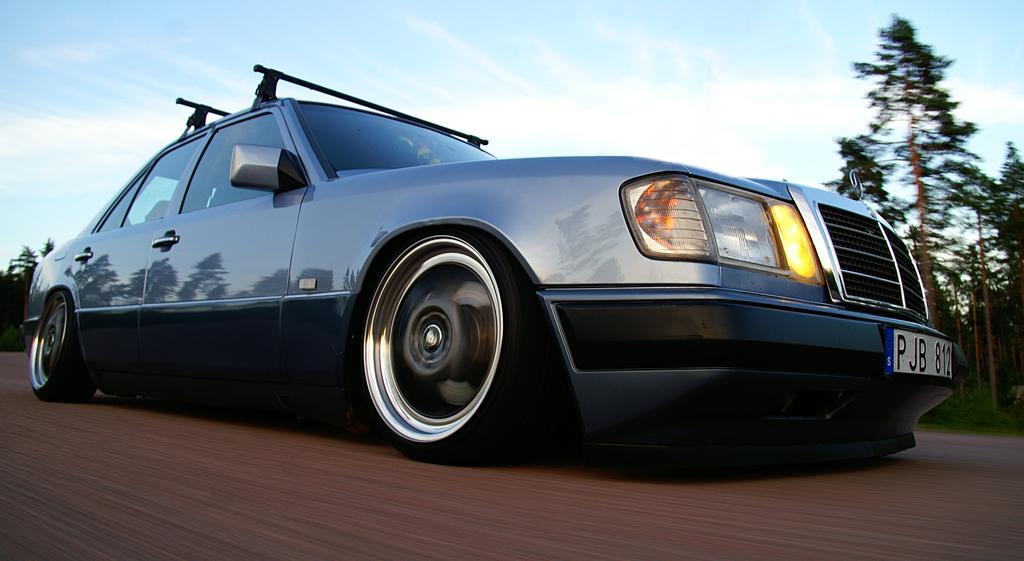Could you give a brief overview of what you see in this image? In the picture we can see a car on the road which is in running position and the car is blue in color with a Mercedes symbol on it and behind it, we can see some trees and grass and in the background we can see a sky with clouds. 